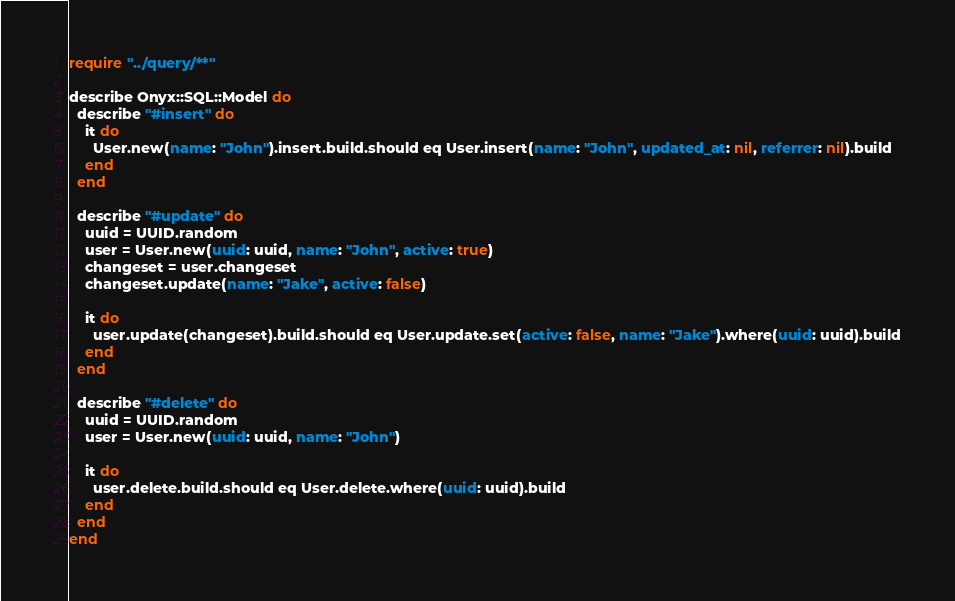Convert code to text. <code><loc_0><loc_0><loc_500><loc_500><_Crystal_>require "../query/**"

describe Onyx::SQL::Model do
  describe "#insert" do
    it do
      User.new(name: "John").insert.build.should eq User.insert(name: "John", updated_at: nil, referrer: nil).build
    end
  end

  describe "#update" do
    uuid = UUID.random
    user = User.new(uuid: uuid, name: "John", active: true)
    changeset = user.changeset
    changeset.update(name: "Jake", active: false)

    it do
      user.update(changeset).build.should eq User.update.set(active: false, name: "Jake").where(uuid: uuid).build
    end
  end

  describe "#delete" do
    uuid = UUID.random
    user = User.new(uuid: uuid, name: "John")

    it do
      user.delete.build.should eq User.delete.where(uuid: uuid).build
    end
  end
end
</code> 